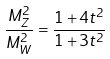<formula> <loc_0><loc_0><loc_500><loc_500>\frac { M ^ { 2 } _ { Z } } { M ^ { 2 } _ { W } } = \frac { 1 + 4 t ^ { 2 } } { 1 + 3 t ^ { 2 } }</formula> 